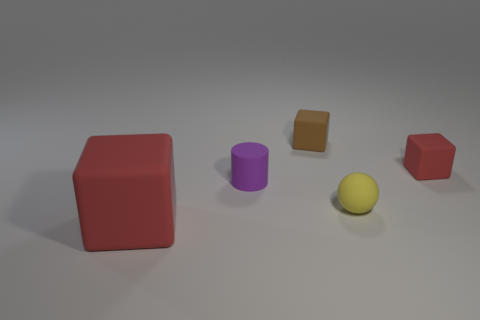Add 5 purple metal blocks. How many objects exist? 10 Subtract all brown blocks. Subtract all purple spheres. How many blocks are left? 2 Subtract all cubes. How many objects are left? 2 Add 5 small matte spheres. How many small matte spheres exist? 6 Subtract 0 gray cylinders. How many objects are left? 5 Subtract all spheres. Subtract all tiny yellow matte spheres. How many objects are left? 3 Add 3 small purple rubber objects. How many small purple rubber objects are left? 4 